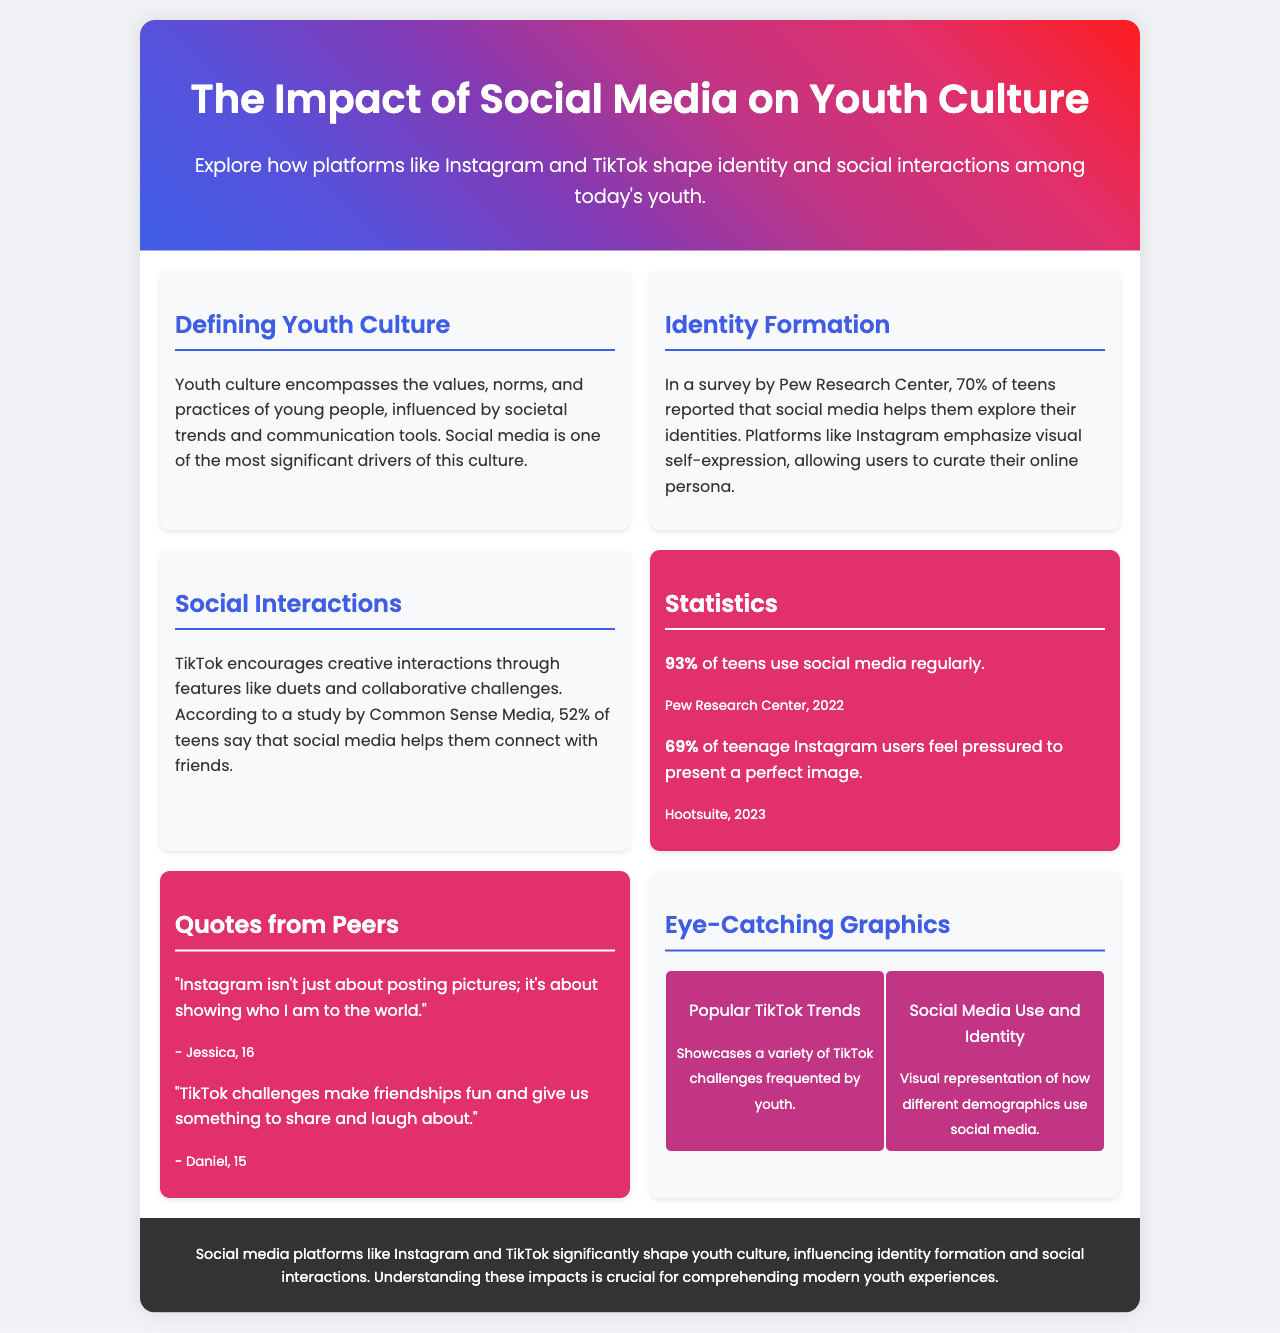What percentage of teens reported that social media helps them explore their identities? The document states that 70% of teens reported that social media helps them explore their identities based on a survey by Pew Research Center.
Answer: 70% What is the main color theme of the brochure header? The header features a gradient background with a blend of several colors, primarily blue, purple, and red.
Answer: Gradient (blue, purple, red) What percentage of teenagers use social media regularly? The document mentions that 93% of teens use social media regularly according to Pew Research Center in 2022.
Answer: 93% Who mentioned that "Instagram isn't just about posting pictures; it's about showing who I am to the world"? The quote is attributed to Jessica, who is 16 years old.
Answer: Jessica What are TikTok challenges said to provide for friendships? According to the document, TikTok challenges give friendships something to share and laugh about.
Answer: Fun (something to share and laugh about) What organization reported that 69% of teenage Instagram users feel pressured to present a perfect image? Hootsuite is the organization that reported this statistic in 2023.
Answer: Hootsuite Which platform emphasizes visual self-expression? The document highlights that Instagram emphasizes visual self-expression, allowing users to curate their online persona.
Answer: Instagram What type of visuals are included in the eye-catching graphics section? The section showcases visually appealing representations of TikTok trends and social media use among different demographics.
Answer: TikTok trends and social media use 